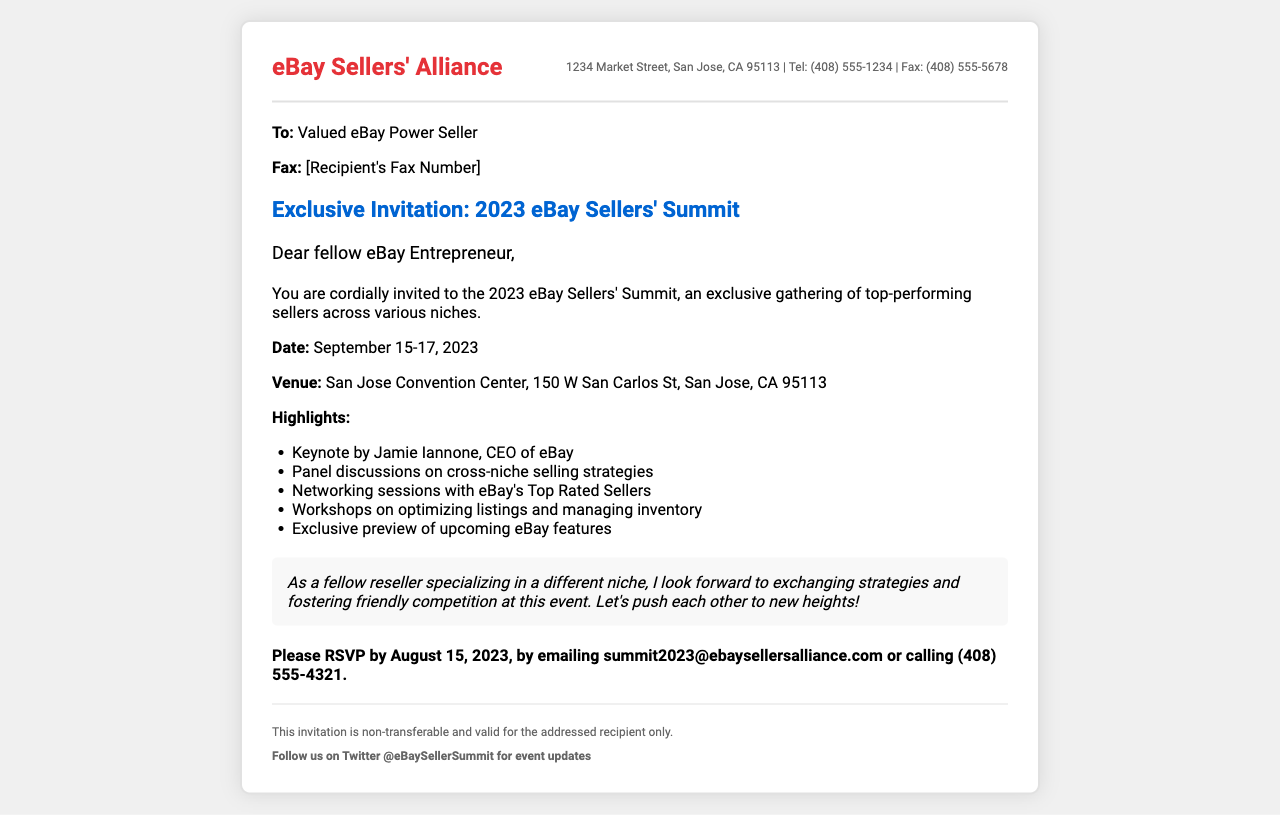What is the date of the summit? The date of the summit is specified in the document as September 15-17, 2023.
Answer: September 15-17, 2023 Who is the keynote speaker? The keynote speaker is mentioned in the main content as Jamie Iannone, the CEO of eBay.
Answer: Jamie Iannone What is the venue for the event? The venue is detailed as the San Jose Convention Center, located at 150 W San Carlos St, San Jose, CA 95113.
Answer: San Jose Convention Center What is the RSVP deadline? The RSVP deadline is stated in the document as August 15, 2023.
Answer: August 15, 2023 What type of event is this invitation for? The event type is described as an exclusive gathering of top-performing sellers across various niches.
Answer: Summit What is one of the workshop topics? One of the workshop topics mentioned is optimizing listings and managing inventory.
Answer: Optimizing listings and managing inventory What is the purpose of the personal note? The personal note expresses the anticipation of exchanging strategies and fostering friendly competition at the event.
Answer: Exchanging strategies and fostering friendly competition How can invitees follow the summit for updates? The document provides a Twitter handle where they can follow for updates: @eBaySellerSummit.
Answer: @eBaySellerSummit Is the invitation transferable? The document states clearly that the invitation is non-transferable and valid for the addressed recipient only.
Answer: Non-transferable 